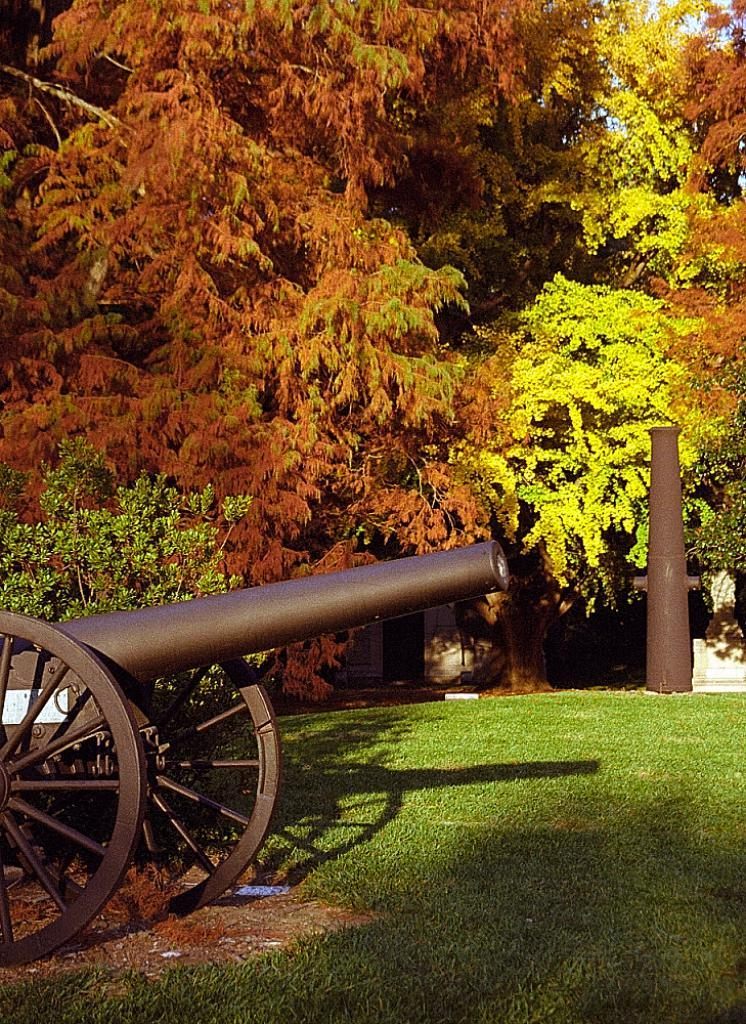What is in the foreground of the picture? There is grass, a canon, and a plant in the foreground of the picture. What can be seen in the background of the picture? There are trees and a pole in the background of the picture. What is the weather like in the image? The image appears to be sunny. Is there a cake being shared by the brothers in the image? There is no cake or brothers present in the image. Can you see any quicksand in the image? There is no quicksand present in the image. 